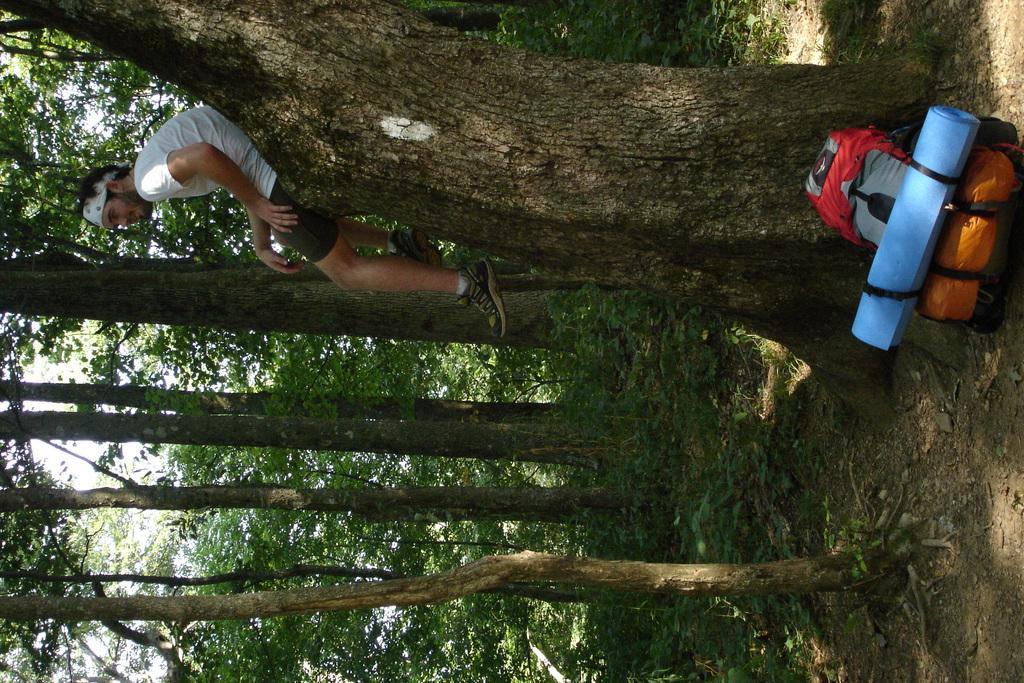Please provide a concise description of this image. In this image, we can see some trees, there is a man sitting on the tree trunk and we can see some bags on the ground, at the top we can see the sky. 